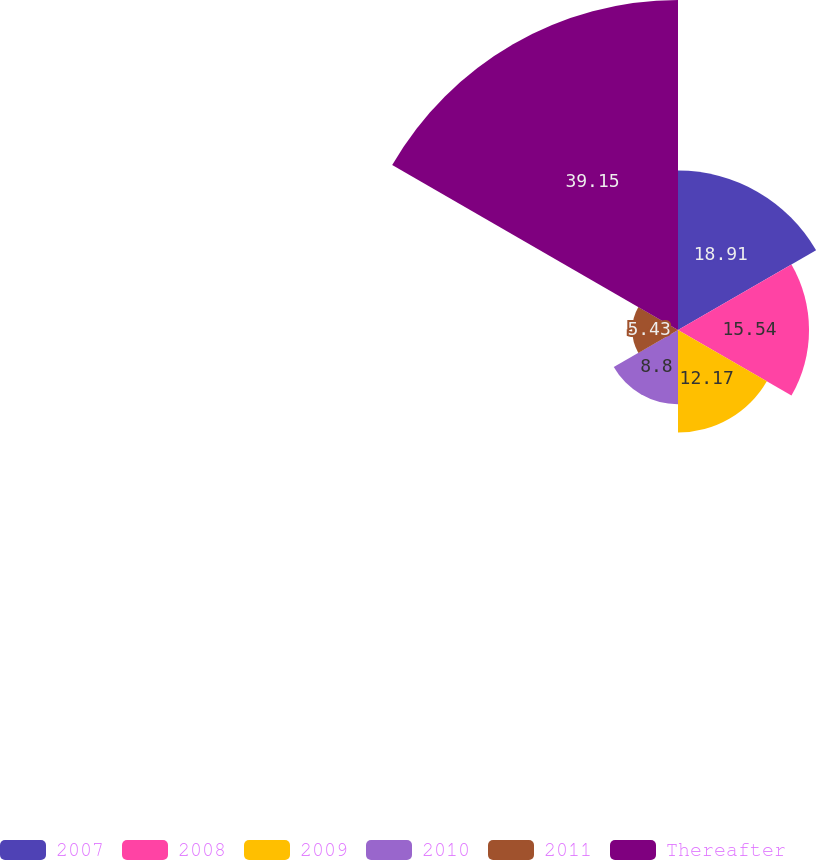Convert chart. <chart><loc_0><loc_0><loc_500><loc_500><pie_chart><fcel>2007<fcel>2008<fcel>2009<fcel>2010<fcel>2011<fcel>Thereafter<nl><fcel>18.91%<fcel>15.54%<fcel>12.17%<fcel>8.8%<fcel>5.43%<fcel>39.14%<nl></chart> 